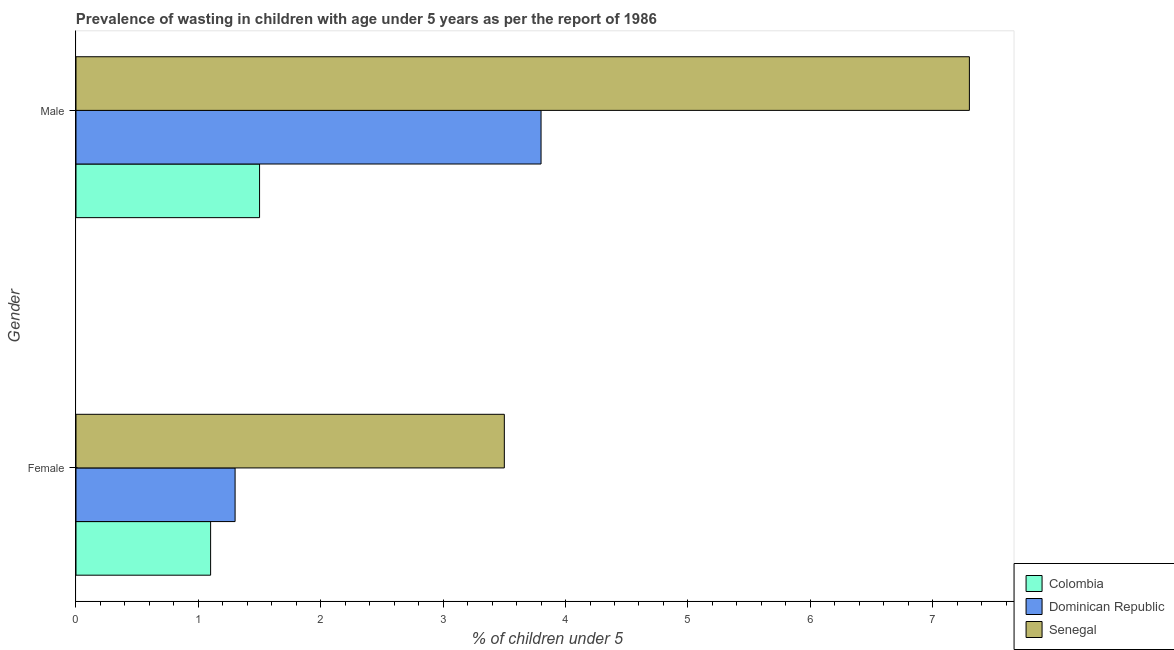How many groups of bars are there?
Keep it short and to the point. 2. Are the number of bars on each tick of the Y-axis equal?
Your answer should be very brief. Yes. How many bars are there on the 1st tick from the top?
Ensure brevity in your answer.  3. How many bars are there on the 2nd tick from the bottom?
Provide a short and direct response. 3. What is the label of the 1st group of bars from the top?
Make the answer very short. Male. What is the percentage of undernourished male children in Colombia?
Offer a terse response. 1.5. Across all countries, what is the maximum percentage of undernourished male children?
Your answer should be compact. 7.3. Across all countries, what is the minimum percentage of undernourished female children?
Provide a short and direct response. 1.1. In which country was the percentage of undernourished female children maximum?
Your answer should be compact. Senegal. What is the total percentage of undernourished female children in the graph?
Keep it short and to the point. 5.9. What is the difference between the percentage of undernourished male children in Senegal and that in Dominican Republic?
Provide a short and direct response. 3.5. What is the difference between the percentage of undernourished male children in Senegal and the percentage of undernourished female children in Colombia?
Your response must be concise. 6.2. What is the average percentage of undernourished female children per country?
Offer a terse response. 1.97. What is the difference between the percentage of undernourished male children and percentage of undernourished female children in Senegal?
Provide a succinct answer. 3.8. In how many countries, is the percentage of undernourished female children greater than 5.6 %?
Make the answer very short. 0. What is the ratio of the percentage of undernourished female children in Colombia to that in Senegal?
Offer a very short reply. 0.31. Is the percentage of undernourished male children in Colombia less than that in Dominican Republic?
Keep it short and to the point. Yes. What does the 2nd bar from the bottom in Female represents?
Make the answer very short. Dominican Republic. How many bars are there?
Provide a succinct answer. 6. Are all the bars in the graph horizontal?
Provide a short and direct response. Yes. How many countries are there in the graph?
Provide a succinct answer. 3. Are the values on the major ticks of X-axis written in scientific E-notation?
Provide a succinct answer. No. Does the graph contain grids?
Offer a very short reply. No. Where does the legend appear in the graph?
Offer a very short reply. Bottom right. How many legend labels are there?
Offer a very short reply. 3. What is the title of the graph?
Your answer should be compact. Prevalence of wasting in children with age under 5 years as per the report of 1986. Does "Thailand" appear as one of the legend labels in the graph?
Keep it short and to the point. No. What is the label or title of the X-axis?
Provide a short and direct response.  % of children under 5. What is the label or title of the Y-axis?
Keep it short and to the point. Gender. What is the  % of children under 5 in Colombia in Female?
Offer a very short reply. 1.1. What is the  % of children under 5 in Dominican Republic in Female?
Ensure brevity in your answer.  1.3. What is the  % of children under 5 of Senegal in Female?
Your response must be concise. 3.5. What is the  % of children under 5 in Dominican Republic in Male?
Your answer should be very brief. 3.8. What is the  % of children under 5 of Senegal in Male?
Provide a short and direct response. 7.3. Across all Gender, what is the maximum  % of children under 5 of Dominican Republic?
Your answer should be compact. 3.8. Across all Gender, what is the maximum  % of children under 5 of Senegal?
Provide a succinct answer. 7.3. Across all Gender, what is the minimum  % of children under 5 in Colombia?
Provide a short and direct response. 1.1. Across all Gender, what is the minimum  % of children under 5 of Dominican Republic?
Keep it short and to the point. 1.3. Across all Gender, what is the minimum  % of children under 5 of Senegal?
Make the answer very short. 3.5. What is the total  % of children under 5 in Colombia in the graph?
Offer a very short reply. 2.6. What is the difference between the  % of children under 5 of Colombia in Female and the  % of children under 5 of Dominican Republic in Male?
Make the answer very short. -2.7. What is the average  % of children under 5 of Dominican Republic per Gender?
Offer a very short reply. 2.55. What is the average  % of children under 5 of Senegal per Gender?
Make the answer very short. 5.4. What is the difference between the  % of children under 5 in Colombia and  % of children under 5 in Senegal in Female?
Keep it short and to the point. -2.4. What is the ratio of the  % of children under 5 in Colombia in Female to that in Male?
Offer a very short reply. 0.73. What is the ratio of the  % of children under 5 of Dominican Republic in Female to that in Male?
Keep it short and to the point. 0.34. What is the ratio of the  % of children under 5 of Senegal in Female to that in Male?
Ensure brevity in your answer.  0.48. What is the difference between the highest and the second highest  % of children under 5 in Colombia?
Make the answer very short. 0.4. What is the difference between the highest and the lowest  % of children under 5 of Dominican Republic?
Offer a terse response. 2.5. What is the difference between the highest and the lowest  % of children under 5 in Senegal?
Provide a succinct answer. 3.8. 